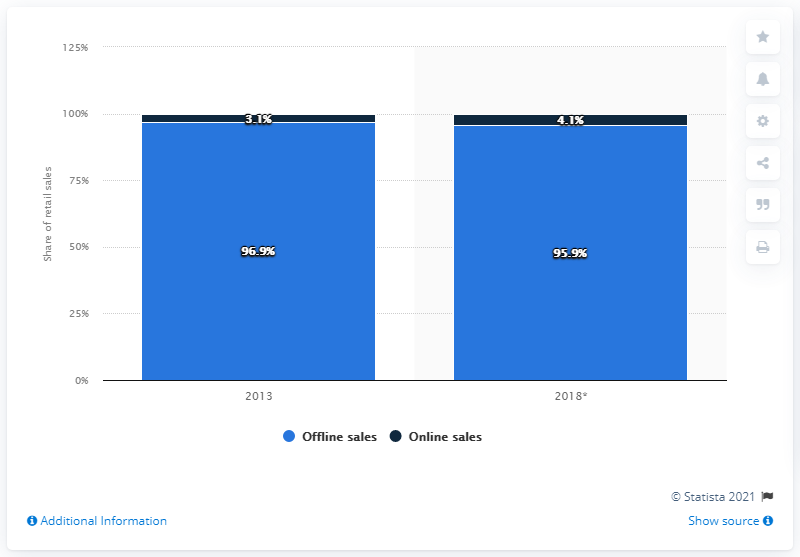Draw attention to some important aspects in this diagram. According to the prediction, the online sales of furniture and floor coverings are expected to increase by 4.1% by 2018. According to data from 2013, online sales of furniture represented 3.1% of total furniture sales that year. In the year 2013, online sales accounted for 3.1 percent of the sales of furniture and floor coverings in Germany. 